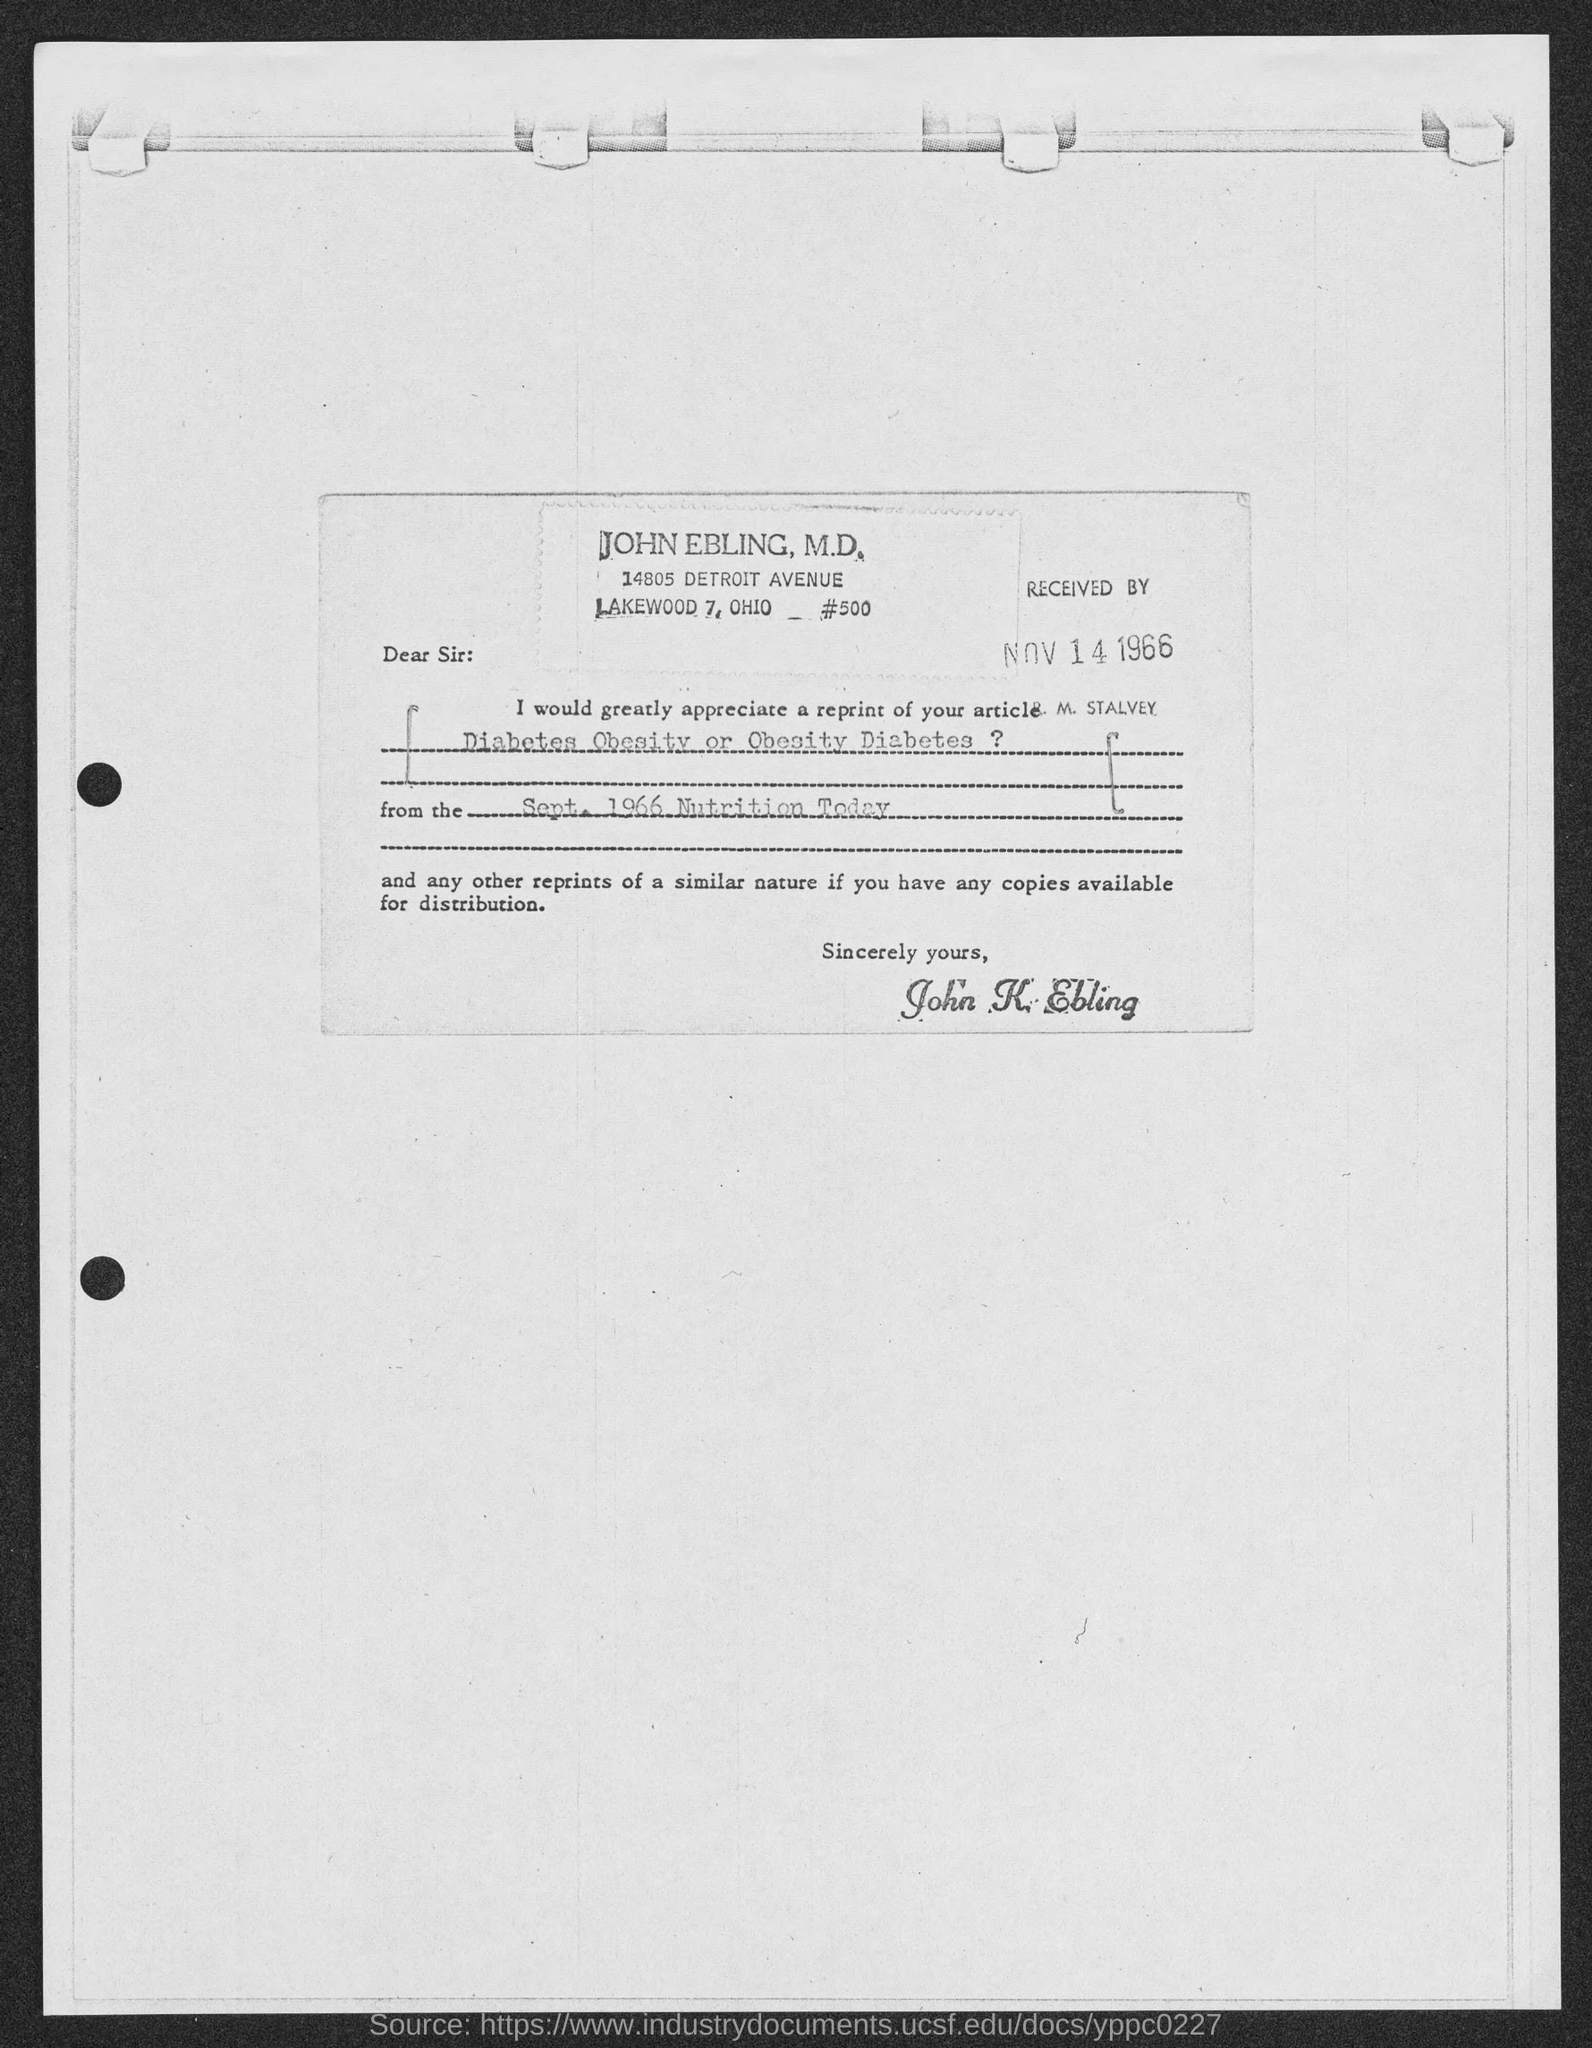Draw attention to some important aspects in this diagram. The name of the magazine is Nutrition Today. The issue date of the article on diabetes, obesity, or obesity diabetes is September 1966. 